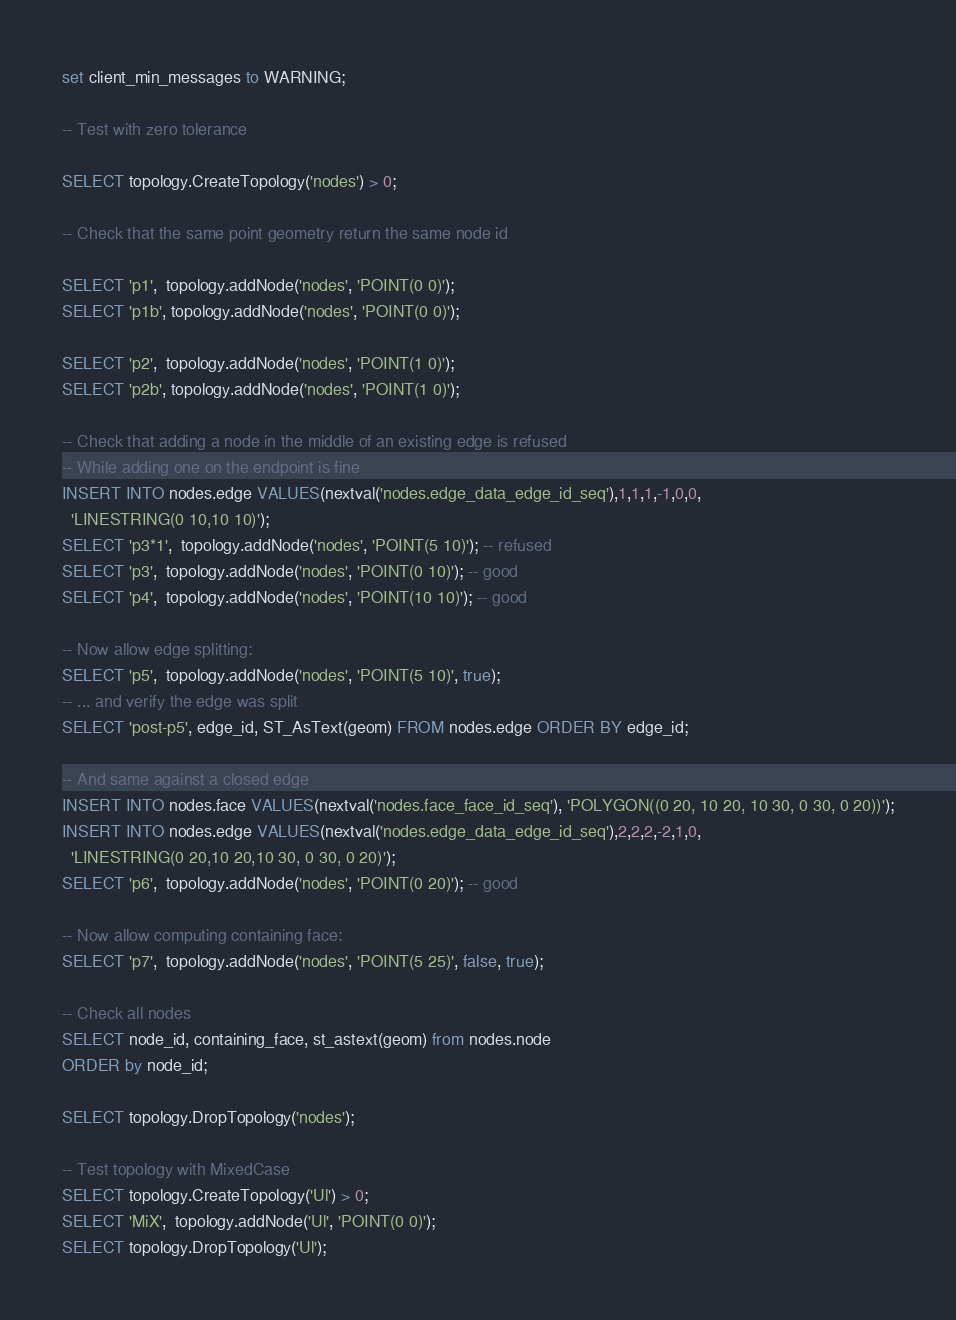Convert code to text. <code><loc_0><loc_0><loc_500><loc_500><_SQL_>set client_min_messages to WARNING;

-- Test with zero tolerance

SELECT topology.CreateTopology('nodes') > 0;

-- Check that the same point geometry return the same node id

SELECT 'p1',  topology.addNode('nodes', 'POINT(0 0)');
SELECT 'p1b', topology.addNode('nodes', 'POINT(0 0)');

SELECT 'p2',  topology.addNode('nodes', 'POINT(1 0)');
SELECT 'p2b', topology.addNode('nodes', 'POINT(1 0)');

-- Check that adding a node in the middle of an existing edge is refused
-- While adding one on the endpoint is fine
INSERT INTO nodes.edge VALUES(nextval('nodes.edge_data_edge_id_seq'),1,1,1,-1,0,0,
  'LINESTRING(0 10,10 10)');
SELECT 'p3*1',  topology.addNode('nodes', 'POINT(5 10)'); -- refused
SELECT 'p3',  topology.addNode('nodes', 'POINT(0 10)'); -- good
SELECT 'p4',  topology.addNode('nodes', 'POINT(10 10)'); -- good

-- Now allow edge splitting:
SELECT 'p5',  topology.addNode('nodes', 'POINT(5 10)', true);
-- ... and verify the edge was split
SELECT 'post-p5', edge_id, ST_AsText(geom) FROM nodes.edge ORDER BY edge_id;

-- And same against a closed edge
INSERT INTO nodes.face VALUES(nextval('nodes.face_face_id_seq'), 'POLYGON((0 20, 10 20, 10 30, 0 30, 0 20))');
INSERT INTO nodes.edge VALUES(nextval('nodes.edge_data_edge_id_seq'),2,2,2,-2,1,0,
  'LINESTRING(0 20,10 20,10 30, 0 30, 0 20)');
SELECT 'p6',  topology.addNode('nodes', 'POINT(0 20)'); -- good

-- Now allow computing containing face:
SELECT 'p7',  topology.addNode('nodes', 'POINT(5 25)', false, true);

-- Check all nodes
SELECT node_id, containing_face, st_astext(geom) from nodes.node
ORDER by node_id;

SELECT topology.DropTopology('nodes');

-- Test topology with MixedCase
SELECT topology.CreateTopology('Ul') > 0;
SELECT 'MiX',  topology.addNode('Ul', 'POINT(0 0)');
SELECT topology.DropTopology('Ul');
</code> 